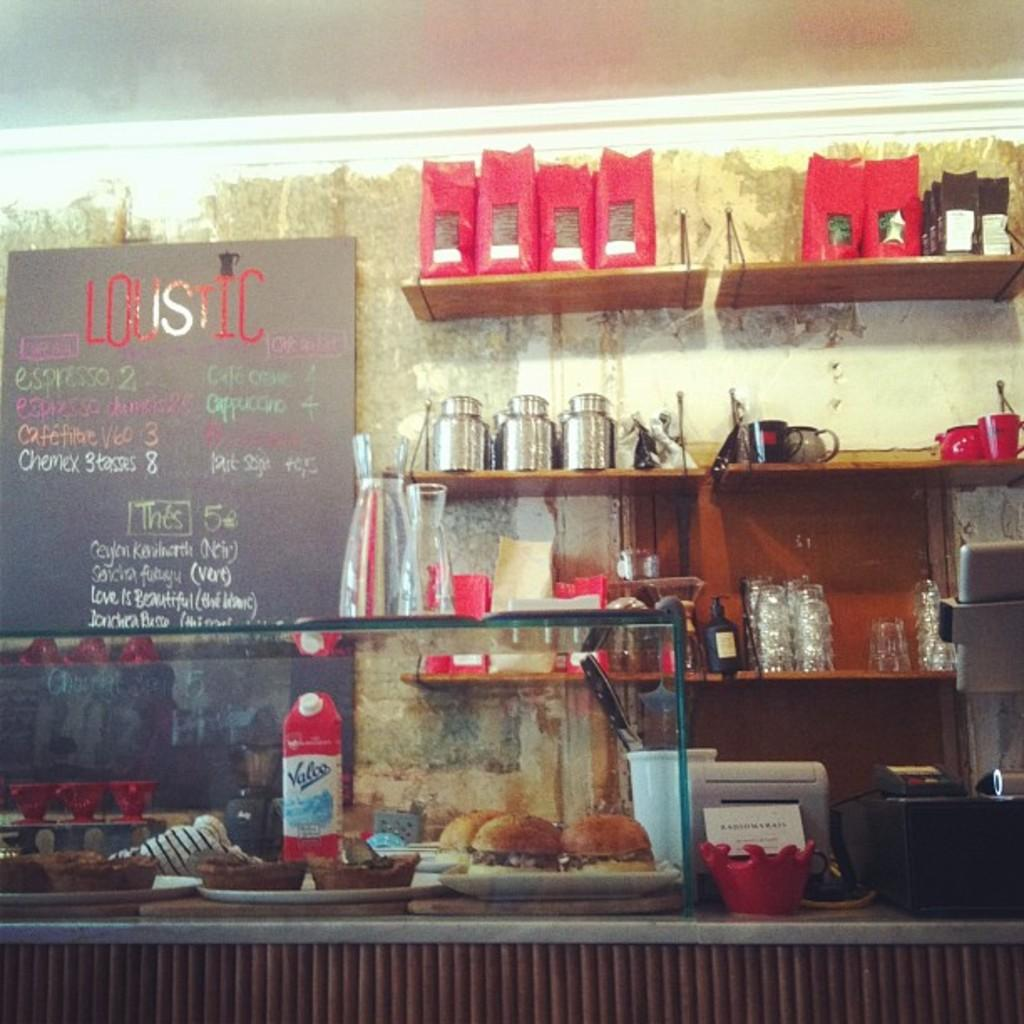<image>
Provide a brief description of the given image. Loustic diner offers their specials on a board behind the counter. 